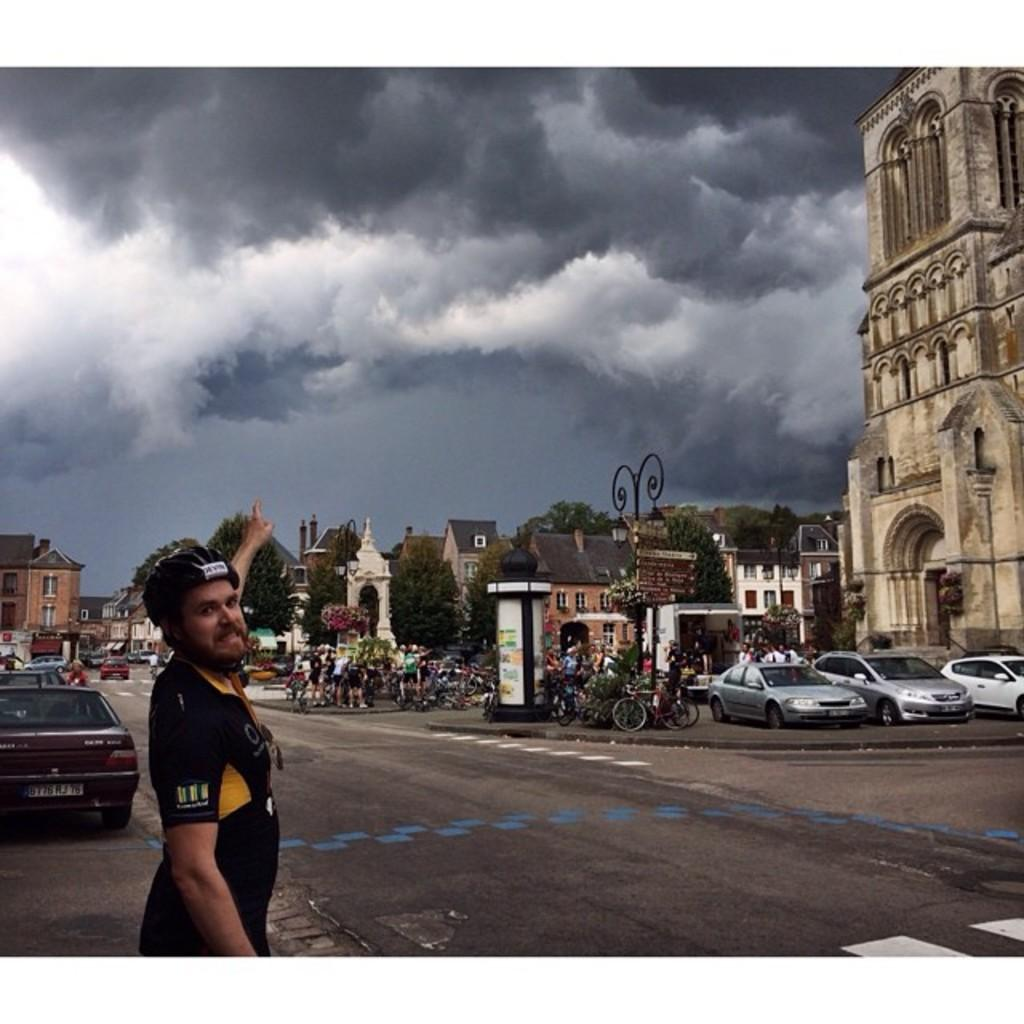Who is in the image? There is a man in the image. What is the main feature of the image? There is a road in the image. What types of vehicles can be seen in the image? Cars and cycles are visible in the image. What can be seen in the background of the image? There are buildings, trees, and a cloudy sky in the background of the image. What type of duck can be seen in the image? There is no duck present in the image. What is the man holding in the image? The man is not holding a picture in the image. 